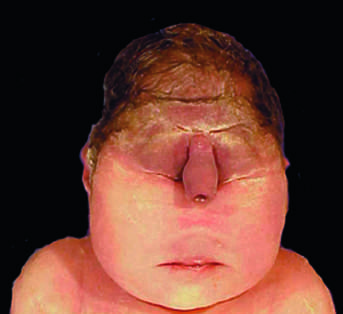s stillbirth associated with a lethal malformation, in which the midface structures are fused or ill-formed?
Answer the question using a single word or phrase. Yes 